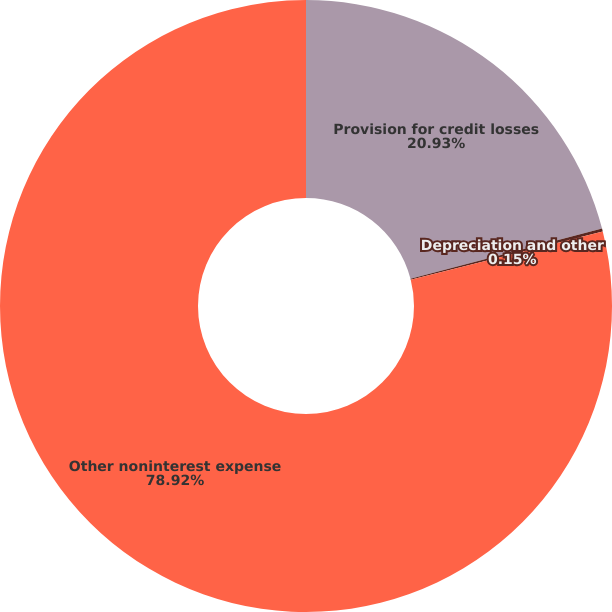<chart> <loc_0><loc_0><loc_500><loc_500><pie_chart><fcel>Provision for credit losses<fcel>Depreciation and other<fcel>Other noninterest expense<nl><fcel>20.93%<fcel>0.15%<fcel>78.92%<nl></chart> 